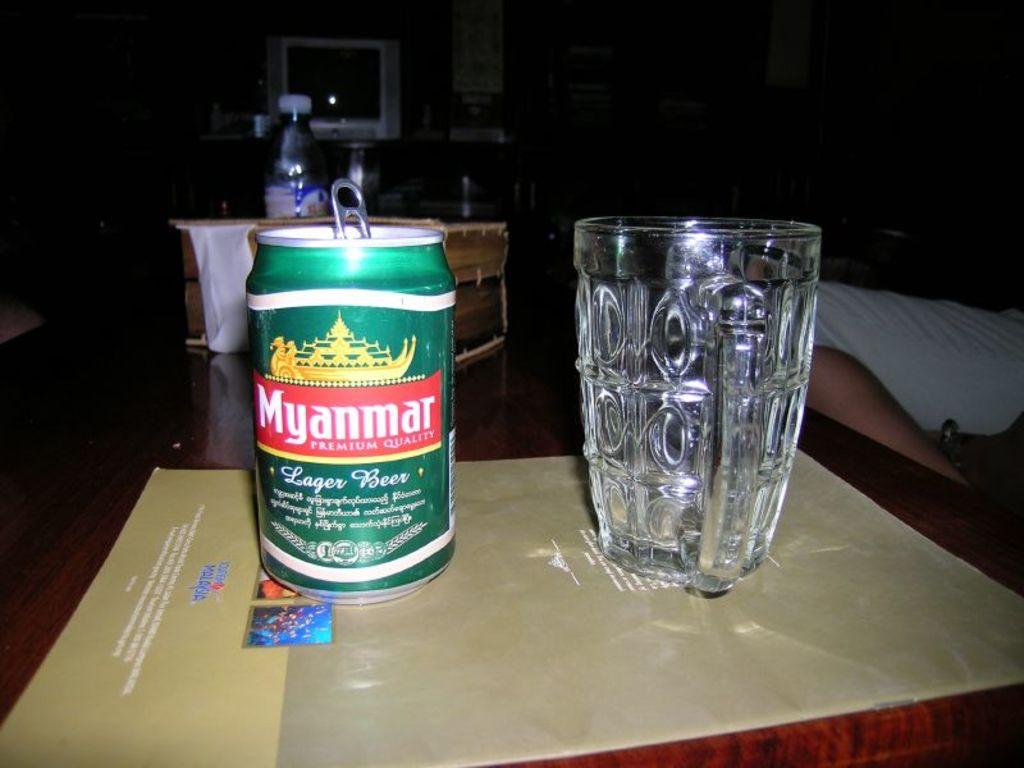<image>
Write a terse but informative summary of the picture. An empty glass is sitting to the right of a can of Myanmar Lager Beer. 